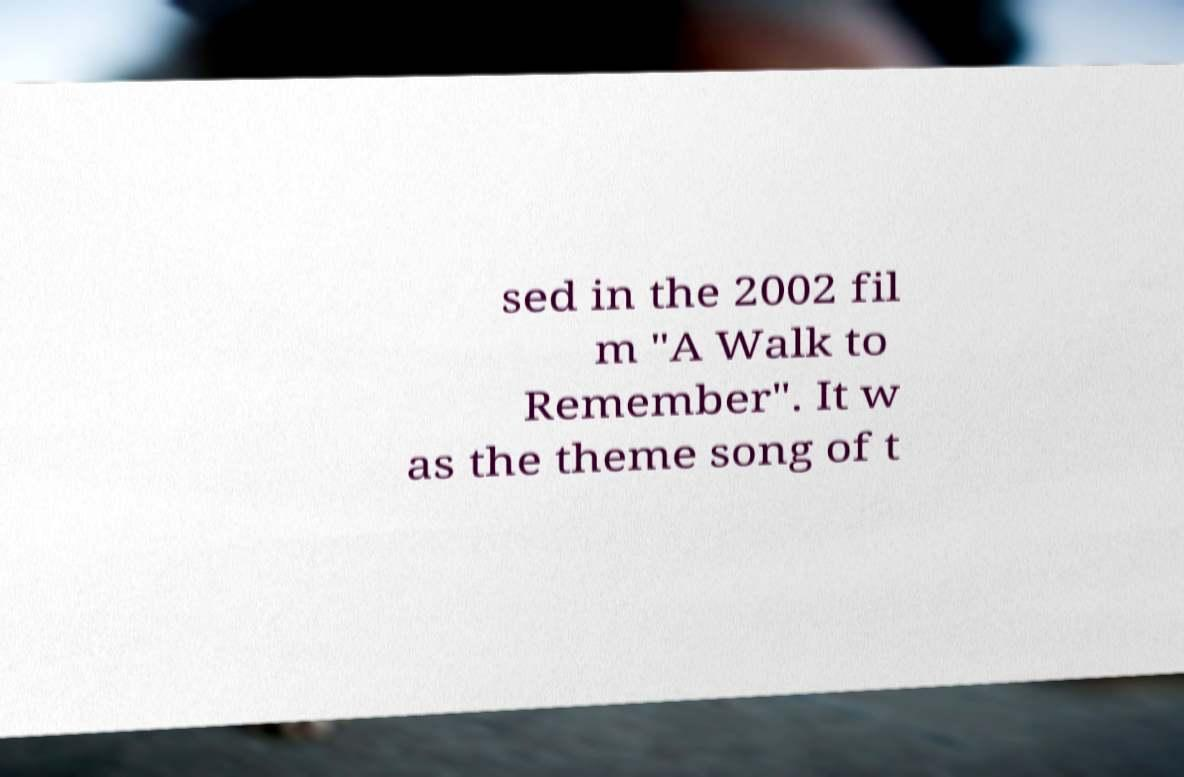Could you extract and type out the text from this image? sed in the 2002 fil m "A Walk to Remember". It w as the theme song of t 